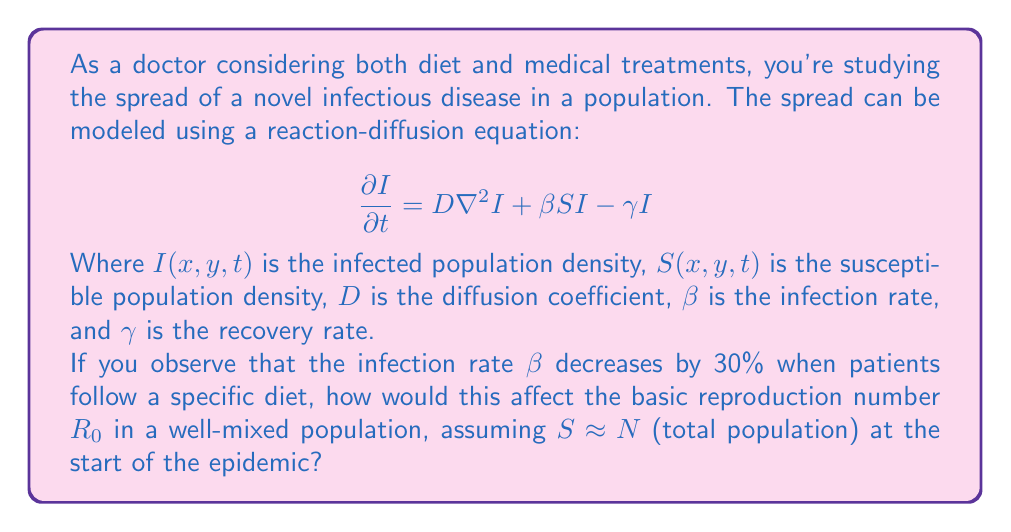What is the answer to this math problem? To solve this problem, we need to understand the concept of the basic reproduction number $R_0$ and how it relates to the parameters in the given partial differential equation.

1) In a well-mixed population (where spatial effects are negligible), we can ignore the diffusion term. The equation becomes:

   $$\frac{dI}{dt} = \beta SI - \gamma I$$

2) The basic reproduction number $R_0$ is defined as the average number of secondary infections caused by one infected individual in a completely susceptible population. In this model, it's given by:

   $$R_0 = \frac{\beta N}{\gamma}$$

   Where $N$ is the total population.

3) Initially, we have:
   
   $$R_0 = \frac{\beta N}{\gamma}$$

4) After the diet intervention, the new infection rate $\beta_{new}$ is 70% of the original $\beta$:

   $$\beta_{new} = 0.7\beta$$

5) The new basic reproduction number $R_0^{new}$ is:

   $$R_0^{new} = \frac{\beta_{new} N}{\gamma} = \frac{0.7\beta N}{\gamma}$$

6) We can express this in terms of the original $R_0$:

   $$R_0^{new} = \frac{0.7\beta N}{\gamma} = 0.7 \cdot \frac{\beta N}{\gamma} = 0.7R_0$$

Therefore, the new basic reproduction number is 70% of the original value.
Answer: The new basic reproduction number $R_0^{new}$ after the dietary intervention is 70% of the original $R_0$, or $R_0^{new} = 0.7R_0$. 